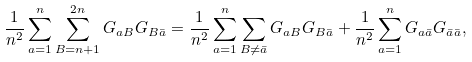Convert formula to latex. <formula><loc_0><loc_0><loc_500><loc_500>\frac { 1 } { n ^ { 2 } } \sum _ { a = 1 } ^ { n } \sum _ { B = n + 1 } ^ { 2 n } G _ { a B } G _ { B \bar { a } } = \frac { 1 } { n ^ { 2 } } \sum _ { a = 1 } ^ { n } \sum _ { B \neq \bar { a } } G _ { a B } G _ { B \bar { a } } + \frac { 1 } { n ^ { 2 } } \sum _ { a = 1 } ^ { n } G _ { a \bar { a } } G _ { \bar { a } \bar { a } } ,</formula> 